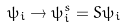Convert formula to latex. <formula><loc_0><loc_0><loc_500><loc_500>\psi _ { i } \rightarrow \psi _ { i } ^ { s } = S \psi _ { i }</formula> 